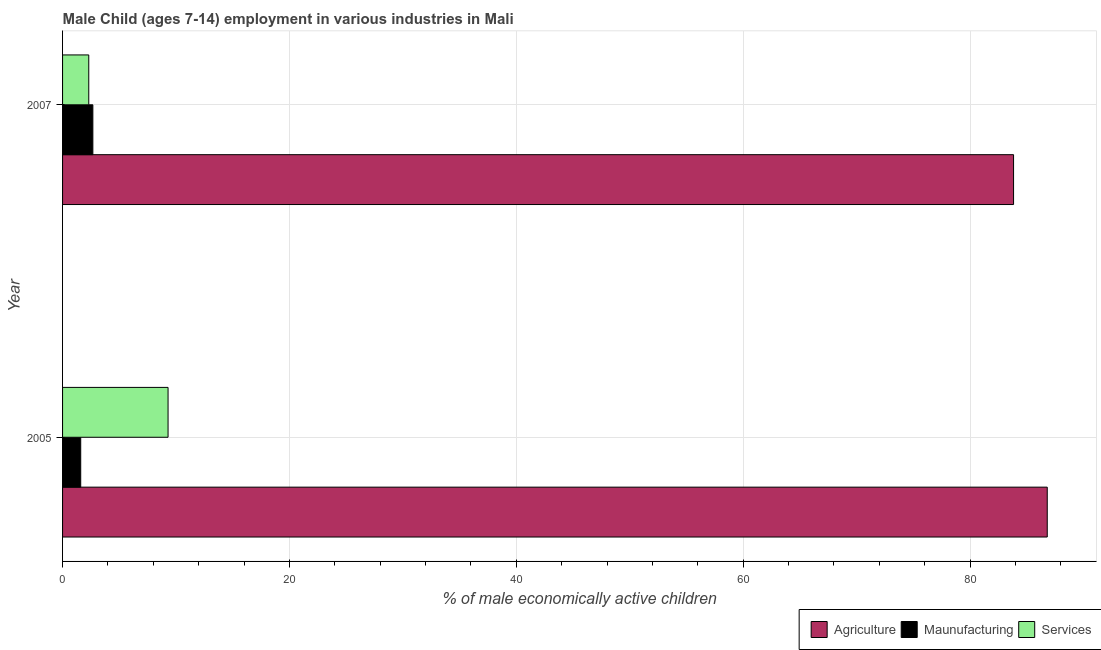How many bars are there on the 2nd tick from the bottom?
Ensure brevity in your answer.  3. What is the percentage of economically active children in services in 2005?
Keep it short and to the point. 9.3. Across all years, what is the maximum percentage of economically active children in services?
Offer a very short reply. 9.3. In which year was the percentage of economically active children in agriculture maximum?
Provide a short and direct response. 2005. What is the total percentage of economically active children in manufacturing in the graph?
Give a very brief answer. 4.27. What is the difference between the percentage of economically active children in services in 2005 and that in 2007?
Your response must be concise. 6.99. What is the difference between the percentage of economically active children in agriculture in 2007 and the percentage of economically active children in services in 2005?
Your response must be concise. 74.53. What is the average percentage of economically active children in services per year?
Your answer should be compact. 5.8. In the year 2005, what is the difference between the percentage of economically active children in agriculture and percentage of economically active children in services?
Your answer should be very brief. 77.5. What is the ratio of the percentage of economically active children in manufacturing in 2005 to that in 2007?
Your response must be concise. 0.6. In how many years, is the percentage of economically active children in agriculture greater than the average percentage of economically active children in agriculture taken over all years?
Your answer should be compact. 1. What does the 1st bar from the top in 2005 represents?
Give a very brief answer. Services. What does the 3rd bar from the bottom in 2005 represents?
Ensure brevity in your answer.  Services. Is it the case that in every year, the sum of the percentage of economically active children in agriculture and percentage of economically active children in manufacturing is greater than the percentage of economically active children in services?
Provide a succinct answer. Yes. How many years are there in the graph?
Provide a short and direct response. 2. Are the values on the major ticks of X-axis written in scientific E-notation?
Offer a terse response. No. Does the graph contain grids?
Your answer should be very brief. Yes. Where does the legend appear in the graph?
Provide a short and direct response. Bottom right. How many legend labels are there?
Ensure brevity in your answer.  3. How are the legend labels stacked?
Your answer should be very brief. Horizontal. What is the title of the graph?
Provide a succinct answer. Male Child (ages 7-14) employment in various industries in Mali. What is the label or title of the X-axis?
Keep it short and to the point. % of male economically active children. What is the label or title of the Y-axis?
Give a very brief answer. Year. What is the % of male economically active children of Agriculture in 2005?
Keep it short and to the point. 86.8. What is the % of male economically active children of Agriculture in 2007?
Provide a short and direct response. 83.83. What is the % of male economically active children in Maunufacturing in 2007?
Make the answer very short. 2.67. What is the % of male economically active children of Services in 2007?
Make the answer very short. 2.31. Across all years, what is the maximum % of male economically active children in Agriculture?
Provide a succinct answer. 86.8. Across all years, what is the maximum % of male economically active children of Maunufacturing?
Offer a terse response. 2.67. Across all years, what is the maximum % of male economically active children in Services?
Offer a very short reply. 9.3. Across all years, what is the minimum % of male economically active children in Agriculture?
Provide a succinct answer. 83.83. Across all years, what is the minimum % of male economically active children in Maunufacturing?
Make the answer very short. 1.6. Across all years, what is the minimum % of male economically active children in Services?
Offer a very short reply. 2.31. What is the total % of male economically active children in Agriculture in the graph?
Offer a very short reply. 170.63. What is the total % of male economically active children of Maunufacturing in the graph?
Make the answer very short. 4.27. What is the total % of male economically active children in Services in the graph?
Make the answer very short. 11.61. What is the difference between the % of male economically active children in Agriculture in 2005 and that in 2007?
Provide a succinct answer. 2.97. What is the difference between the % of male economically active children of Maunufacturing in 2005 and that in 2007?
Your answer should be very brief. -1.07. What is the difference between the % of male economically active children in Services in 2005 and that in 2007?
Ensure brevity in your answer.  6.99. What is the difference between the % of male economically active children of Agriculture in 2005 and the % of male economically active children of Maunufacturing in 2007?
Keep it short and to the point. 84.13. What is the difference between the % of male economically active children of Agriculture in 2005 and the % of male economically active children of Services in 2007?
Offer a terse response. 84.49. What is the difference between the % of male economically active children of Maunufacturing in 2005 and the % of male economically active children of Services in 2007?
Provide a succinct answer. -0.71. What is the average % of male economically active children in Agriculture per year?
Keep it short and to the point. 85.31. What is the average % of male economically active children of Maunufacturing per year?
Give a very brief answer. 2.13. What is the average % of male economically active children of Services per year?
Offer a terse response. 5.8. In the year 2005, what is the difference between the % of male economically active children in Agriculture and % of male economically active children in Maunufacturing?
Provide a succinct answer. 85.2. In the year 2005, what is the difference between the % of male economically active children in Agriculture and % of male economically active children in Services?
Ensure brevity in your answer.  77.5. In the year 2005, what is the difference between the % of male economically active children in Maunufacturing and % of male economically active children in Services?
Ensure brevity in your answer.  -7.7. In the year 2007, what is the difference between the % of male economically active children of Agriculture and % of male economically active children of Maunufacturing?
Offer a terse response. 81.16. In the year 2007, what is the difference between the % of male economically active children in Agriculture and % of male economically active children in Services?
Offer a very short reply. 81.52. In the year 2007, what is the difference between the % of male economically active children in Maunufacturing and % of male economically active children in Services?
Provide a succinct answer. 0.36. What is the ratio of the % of male economically active children of Agriculture in 2005 to that in 2007?
Ensure brevity in your answer.  1.04. What is the ratio of the % of male economically active children of Maunufacturing in 2005 to that in 2007?
Ensure brevity in your answer.  0.6. What is the ratio of the % of male economically active children of Services in 2005 to that in 2007?
Provide a short and direct response. 4.03. What is the difference between the highest and the second highest % of male economically active children of Agriculture?
Offer a terse response. 2.97. What is the difference between the highest and the second highest % of male economically active children in Maunufacturing?
Make the answer very short. 1.07. What is the difference between the highest and the second highest % of male economically active children in Services?
Provide a short and direct response. 6.99. What is the difference between the highest and the lowest % of male economically active children in Agriculture?
Keep it short and to the point. 2.97. What is the difference between the highest and the lowest % of male economically active children in Maunufacturing?
Provide a succinct answer. 1.07. What is the difference between the highest and the lowest % of male economically active children of Services?
Your answer should be very brief. 6.99. 